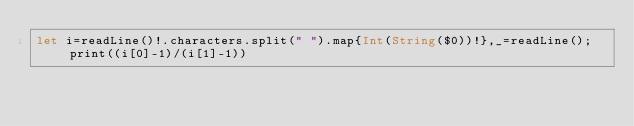<code> <loc_0><loc_0><loc_500><loc_500><_Swift_>let i=readLine()!.characters.split(" ").map{Int(String($0))!},_=readLine();print((i[0]-1)/(i[1]-1))</code> 